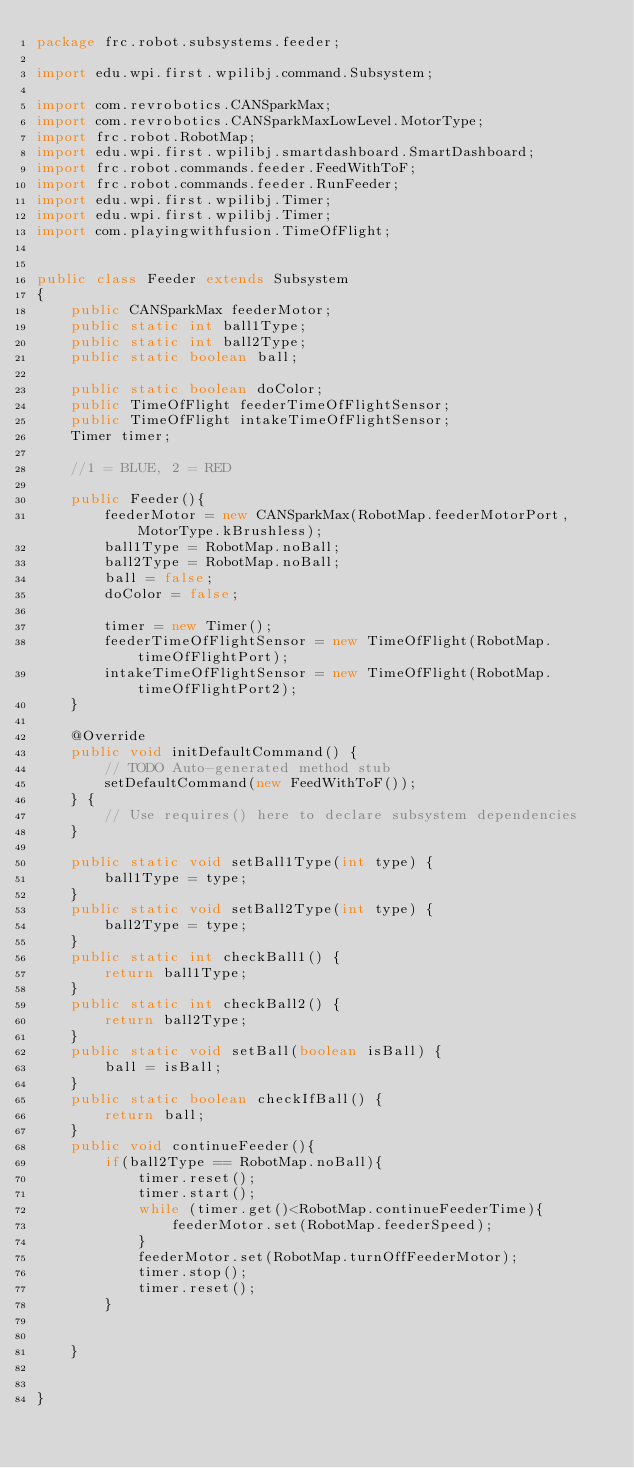<code> <loc_0><loc_0><loc_500><loc_500><_Java_>package frc.robot.subsystems.feeder;

import edu.wpi.first.wpilibj.command.Subsystem;

import com.revrobotics.CANSparkMax;
import com.revrobotics.CANSparkMaxLowLevel.MotorType;
import frc.robot.RobotMap;
import edu.wpi.first.wpilibj.smartdashboard.SmartDashboard;
import frc.robot.commands.feeder.FeedWithToF;
import frc.robot.commands.feeder.RunFeeder;
import edu.wpi.first.wpilibj.Timer;
import edu.wpi.first.wpilibj.Timer;
import com.playingwithfusion.TimeOfFlight;


public class Feeder extends Subsystem
{
    public CANSparkMax feederMotor;
    public static int ball1Type;
    public static int ball2Type;
    public static boolean ball;
    
    public static boolean doColor;
    public TimeOfFlight feederTimeOfFlightSensor;
    public TimeOfFlight intakeTimeOfFlightSensor;
    Timer timer;
    
    //1 = BLUE, 2 = RED

    public Feeder(){
        feederMotor = new CANSparkMax(RobotMap.feederMotorPort, MotorType.kBrushless);
        ball1Type = RobotMap.noBall;
        ball2Type = RobotMap.noBall;
        ball = false;
        doColor = false;
        
        timer = new Timer();
        feederTimeOfFlightSensor = new TimeOfFlight(RobotMap.timeOfFlightPort);
        intakeTimeOfFlightSensor = new TimeOfFlight(RobotMap.timeOfFlightPort2);
    } 
    
    @Override
    public void initDefaultCommand() {
        // TODO Auto-generated method stub
        setDefaultCommand(new FeedWithToF());
    } {
		// Use requires() here to declare subsystem dependencies
	}

    public static void setBall1Type(int type) {
        ball1Type = type;
    }
    public static void setBall2Type(int type) {
        ball2Type = type;
    }
    public static int checkBall1() {
        return ball1Type;
    }
    public static int checkBall2() {
        return ball2Type;
    }
    public static void setBall(boolean isBall) {
        ball = isBall;
    }
    public static boolean checkIfBall() {
        return ball;
    }
    public void continueFeeder(){
        if(ball2Type == RobotMap.noBall){
            timer.reset();
            timer.start();
            while (timer.get()<RobotMap.continueFeederTime){
                feederMotor.set(RobotMap.feederSpeed);
            } 
            feederMotor.set(RobotMap.turnOffFeederMotor);
            timer.stop();
            timer.reset();
        }

        
    }

	
}
</code> 